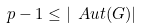Convert formula to latex. <formula><loc_0><loc_0><loc_500><loc_500>p - 1 \leq | \ A u t ( G ) |</formula> 